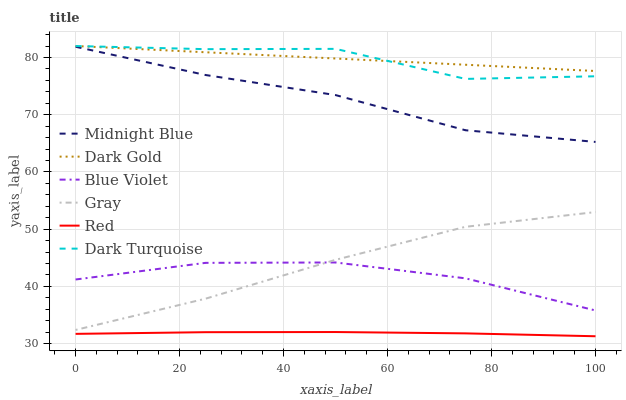Does Red have the minimum area under the curve?
Answer yes or no. Yes. Does Dark Gold have the maximum area under the curve?
Answer yes or no. Yes. Does Midnight Blue have the minimum area under the curve?
Answer yes or no. No. Does Midnight Blue have the maximum area under the curve?
Answer yes or no. No. Is Dark Gold the smoothest?
Answer yes or no. Yes. Is Dark Turquoise the roughest?
Answer yes or no. Yes. Is Midnight Blue the smoothest?
Answer yes or no. No. Is Midnight Blue the roughest?
Answer yes or no. No. Does Red have the lowest value?
Answer yes or no. Yes. Does Midnight Blue have the lowest value?
Answer yes or no. No. Does Dark Turquoise have the highest value?
Answer yes or no. Yes. Does Midnight Blue have the highest value?
Answer yes or no. No. Is Gray less than Midnight Blue?
Answer yes or no. Yes. Is Dark Turquoise greater than Gray?
Answer yes or no. Yes. Does Dark Gold intersect Dark Turquoise?
Answer yes or no. Yes. Is Dark Gold less than Dark Turquoise?
Answer yes or no. No. Is Dark Gold greater than Dark Turquoise?
Answer yes or no. No. Does Gray intersect Midnight Blue?
Answer yes or no. No. 